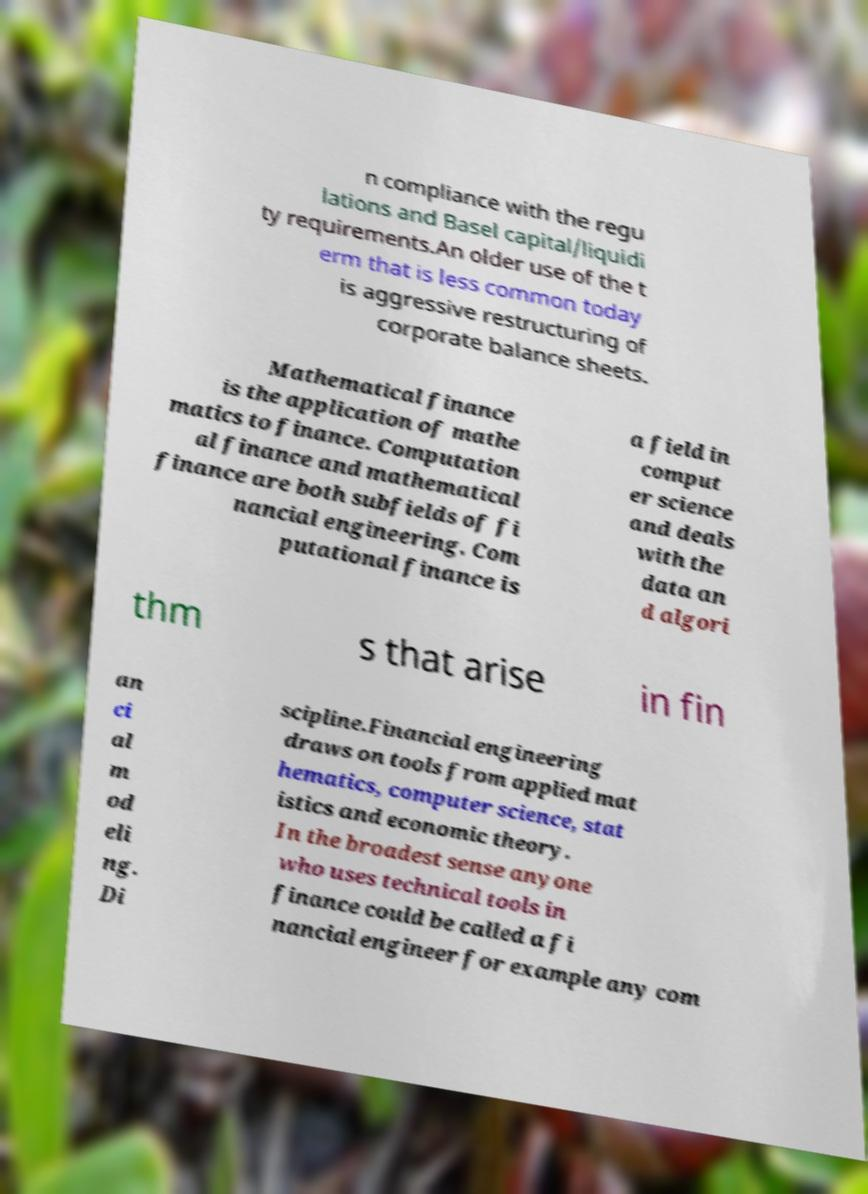Please read and relay the text visible in this image. What does it say? n compliance with the regu lations and Basel capital/liquidi ty requirements.An older use of the t erm that is less common today is aggressive restructuring of corporate balance sheets. Mathematical finance is the application of mathe matics to finance. Computation al finance and mathematical finance are both subfields of fi nancial engineering. Com putational finance is a field in comput er science and deals with the data an d algori thm s that arise in fin an ci al m od eli ng. Di scipline.Financial engineering draws on tools from applied mat hematics, computer science, stat istics and economic theory. In the broadest sense anyone who uses technical tools in finance could be called a fi nancial engineer for example any com 